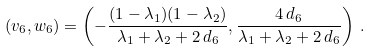<formula> <loc_0><loc_0><loc_500><loc_500>\left ( v _ { 6 } , w _ { 6 } \right ) = \left ( - \frac { ( 1 - \lambda _ { 1 } ) ( 1 - \lambda _ { 2 } ) } { \lambda _ { 1 } + \lambda _ { 2 } + 2 \, d _ { 6 } } , \frac { 4 \, d _ { 6 } } { \lambda _ { 1 } + \lambda _ { 2 } + 2 \, d _ { 6 } } \right ) \, .</formula> 